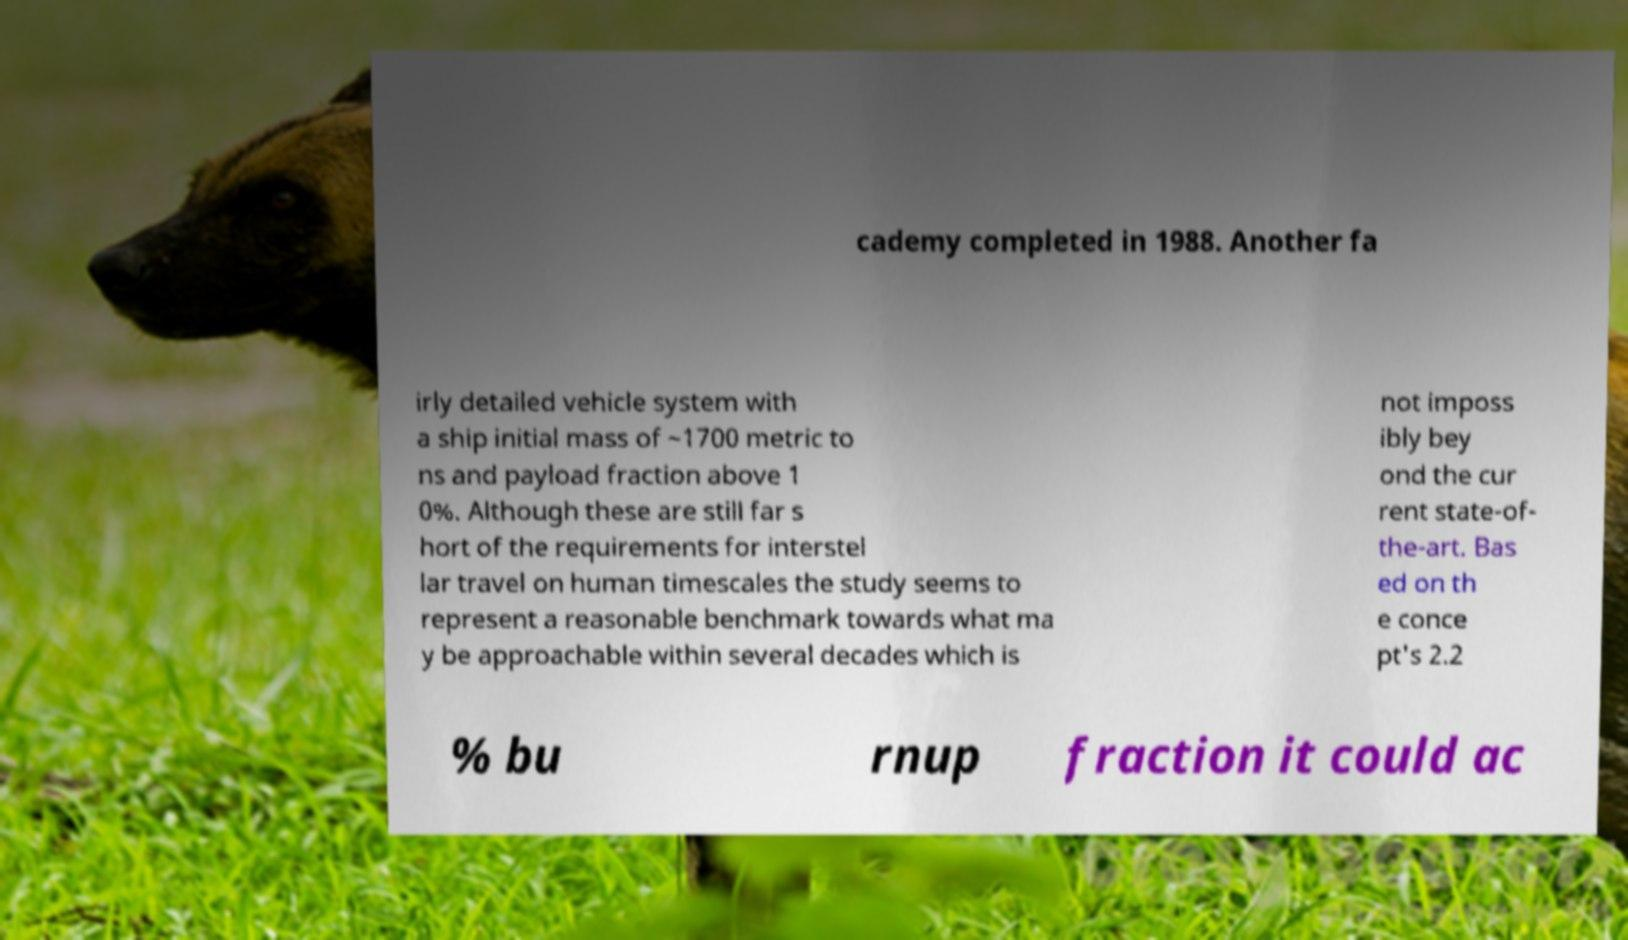What messages or text are displayed in this image? I need them in a readable, typed format. cademy completed in 1988. Another fa irly detailed vehicle system with a ship initial mass of ~1700 metric to ns and payload fraction above 1 0%. Although these are still far s hort of the requirements for interstel lar travel on human timescales the study seems to represent a reasonable benchmark towards what ma y be approachable within several decades which is not imposs ibly bey ond the cur rent state-of- the-art. Bas ed on th e conce pt's 2.2 % bu rnup fraction it could ac 